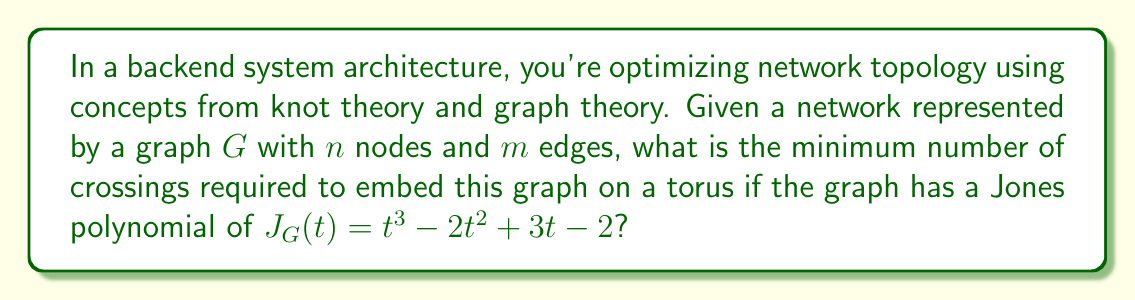Teach me how to tackle this problem. 1. First, we need to understand the relationship between knot theory and graph theory in this context:
   - The network topology can be represented as a graph embedded on a surface (in this case, a torus).
   - The number of crossings in this embedding is related to the complexity of the network topology.

2. The Jones polynomial $J_G(t)$ is given as $t^3 - 2t^2 + 3t - 2$. In knot theory, the degree of the Jones polynomial is related to the crossing number of the knot or link.

3. For a graph $G$ embedded on a torus, we can use the following formula to calculate the minimum number of crossings:

   $$c_{min} = \frac{1}{2}(deg(J_G) - (n - m) + 1)$$

   Where:
   - $c_{min}$ is the minimum number of crossings
   - $deg(J_G)$ is the degree of the Jones polynomial
   - $n$ is the number of nodes
   - $m$ is the number of edges

4. From the given Jones polynomial, we can see that $deg(J_G) = 3$.

5. We don't have specific values for $n$ and $m$, but we know that $n - m$ represents the Euler characteristic of the graph, which is always 0 for a graph embedded on a torus.

6. Substituting these values into the formula:

   $$c_{min} = \frac{1}{2}(3 - (n - m) + 1) = \frac{1}{2}(3 - 0 + 1) = \frac{1}{2}(4) = 2$$

Therefore, the minimum number of crossings required to embed this graph on a torus is 2.
Answer: 2 